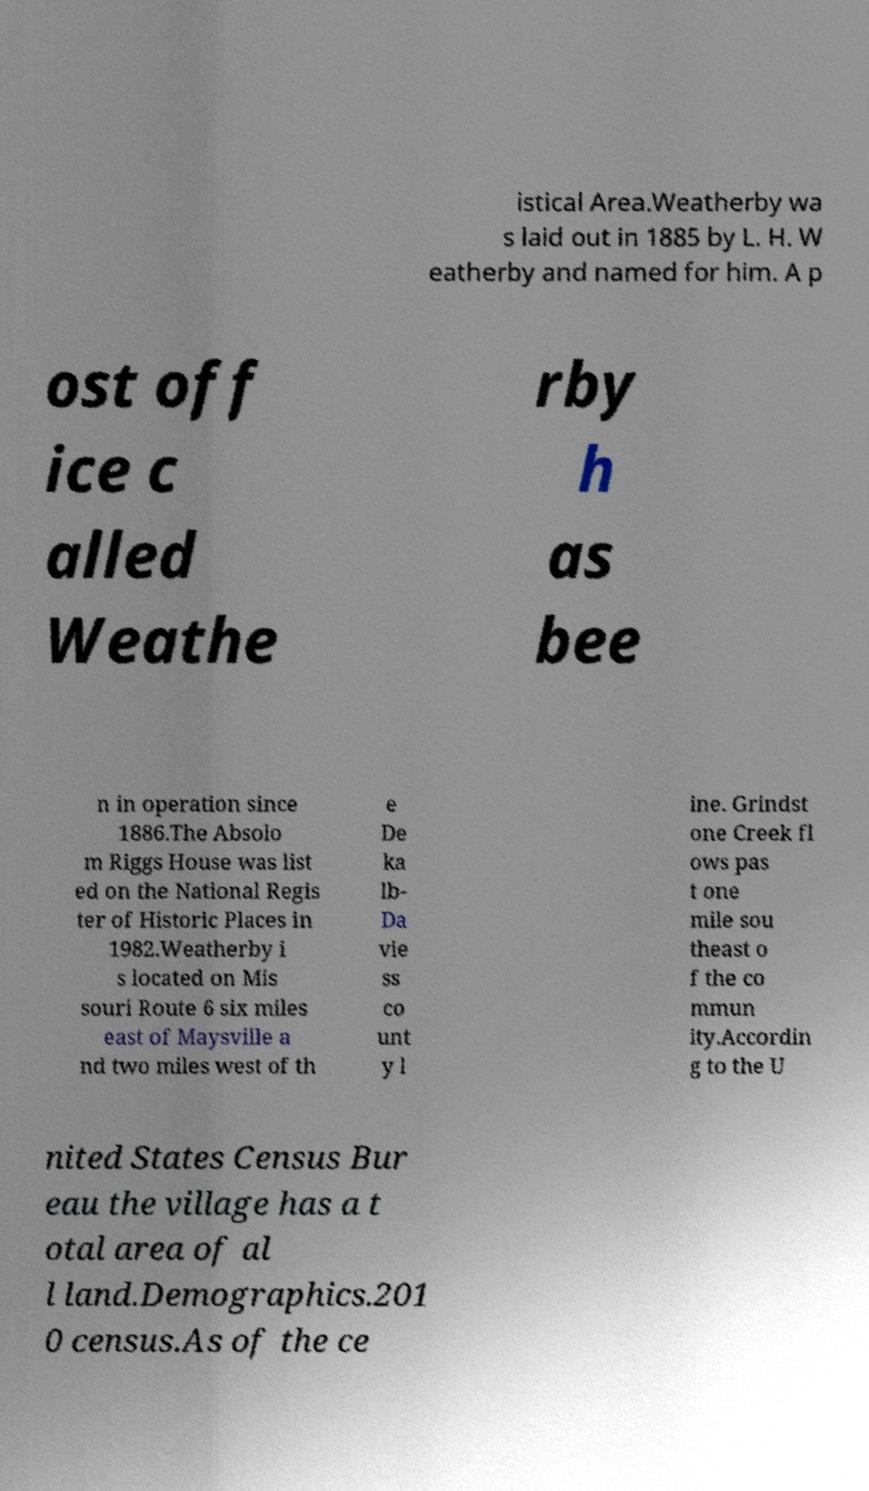Can you read and provide the text displayed in the image?This photo seems to have some interesting text. Can you extract and type it out for me? istical Area.Weatherby wa s laid out in 1885 by L. H. W eatherby and named for him. A p ost off ice c alled Weathe rby h as bee n in operation since 1886.The Absolo m Riggs House was list ed on the National Regis ter of Historic Places in 1982.Weatherby i s located on Mis souri Route 6 six miles east of Maysville a nd two miles west of th e De ka lb- Da vie ss co unt y l ine. Grindst one Creek fl ows pas t one mile sou theast o f the co mmun ity.Accordin g to the U nited States Census Bur eau the village has a t otal area of al l land.Demographics.201 0 census.As of the ce 